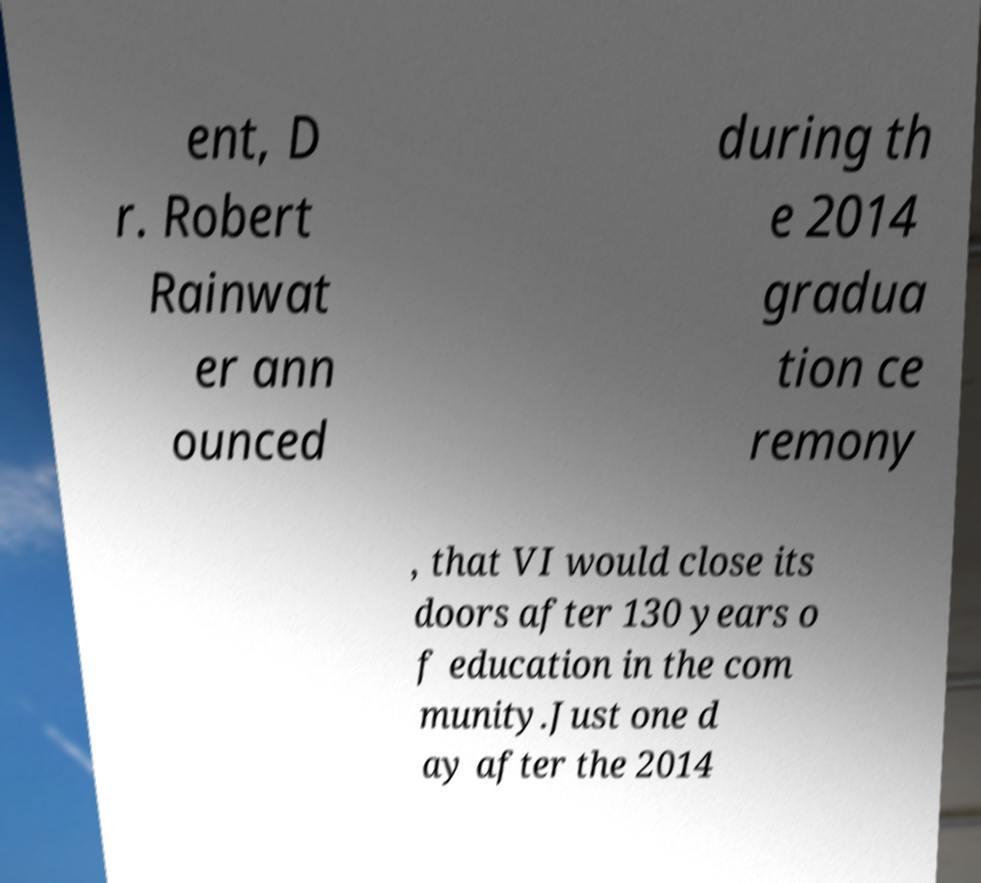There's text embedded in this image that I need extracted. Can you transcribe it verbatim? ent, D r. Robert Rainwat er ann ounced during th e 2014 gradua tion ce remony , that VI would close its doors after 130 years o f education in the com munity.Just one d ay after the 2014 